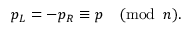Convert formula to latex. <formula><loc_0><loc_0><loc_500><loc_500>p _ { L } = - p _ { R } \equiv p \quad ( m o d \, n ) .</formula> 